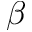<formula> <loc_0><loc_0><loc_500><loc_500>\beta</formula> 